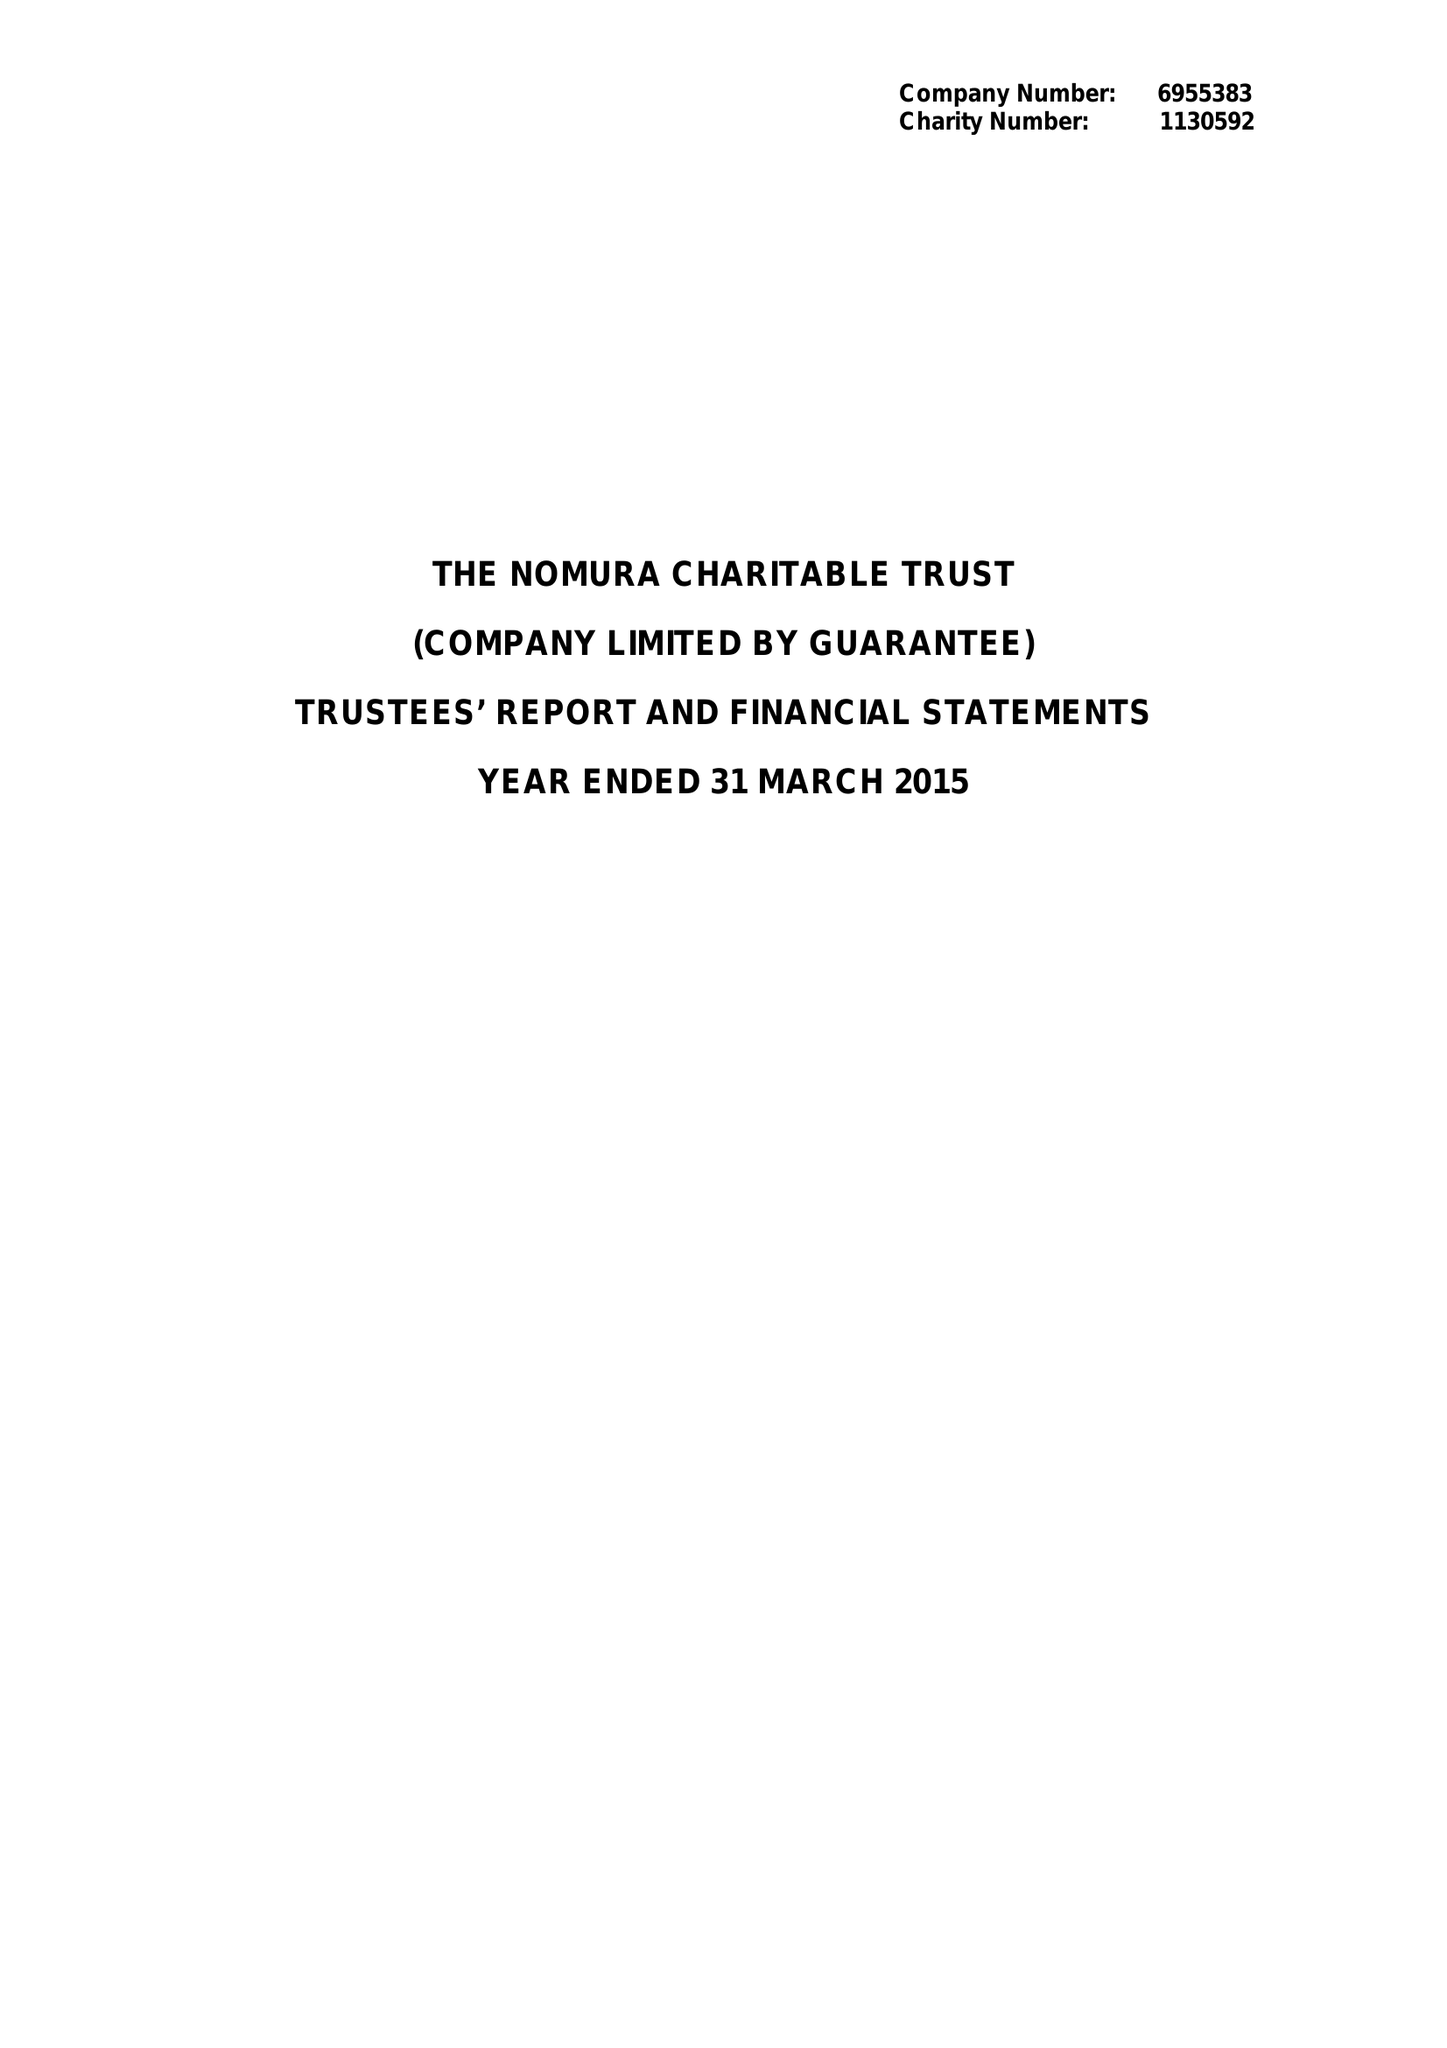What is the value for the charity_number?
Answer the question using a single word or phrase. 1130592 